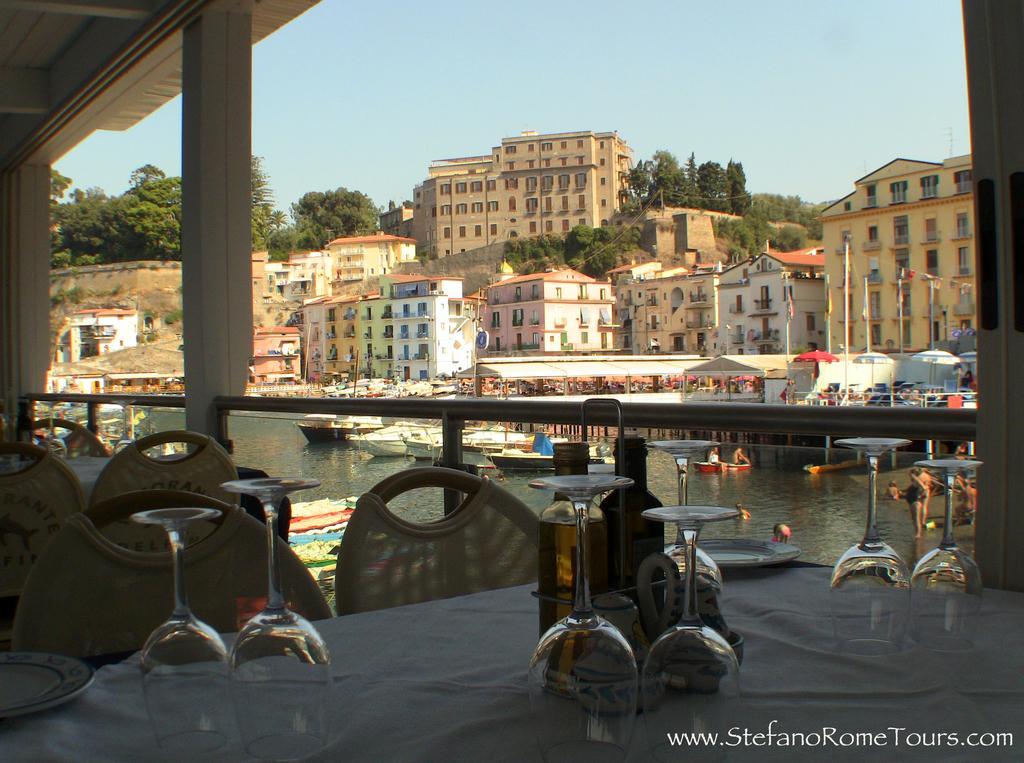Please provide a concise description of this image. In this image, we can see a table contains some glasses. There are chairs in the bottom left of the image. There are boats floating on the water. There are some buildings and trees in the middle of the image. There is a sky at the top of the image. 